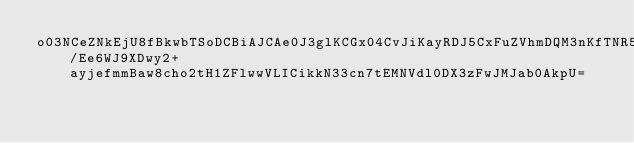Convert code to text. <code><loc_0><loc_0><loc_500><loc_500><_SML_>o03NCeZNkEjU8fBkwbTSoDCBiAJCAe0J3glKCGx04CvJiKayRDJ5CxFuZVhmDQM3nKfTNR5EzuMdSzWXcdp3q2DcmV0IAwlVttzxbwTcGLTKCioyp1CxAkIAu3NCj1WUwpvkW5/Ee6WJ9XDwy2+ayjefmmBaw8cho2tH1ZFlwwVLICikkN33cn7tEMNVdl0DX3zFwJMJab0AkpU=</code> 